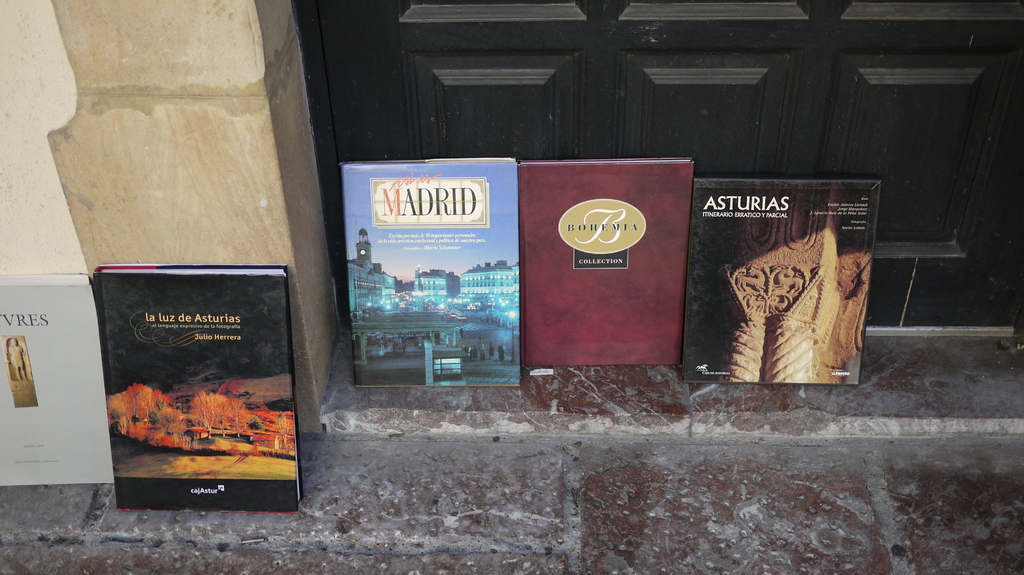How might the design and presentation of these books influence a potential reader's interest? The striking covers and strategic placement by the building's entrance are designed to capture attention; the vibrant photographs and elegant typography of each book suggest a high-quality, visually and intellectually engaging exploration into each region's unique charm. 